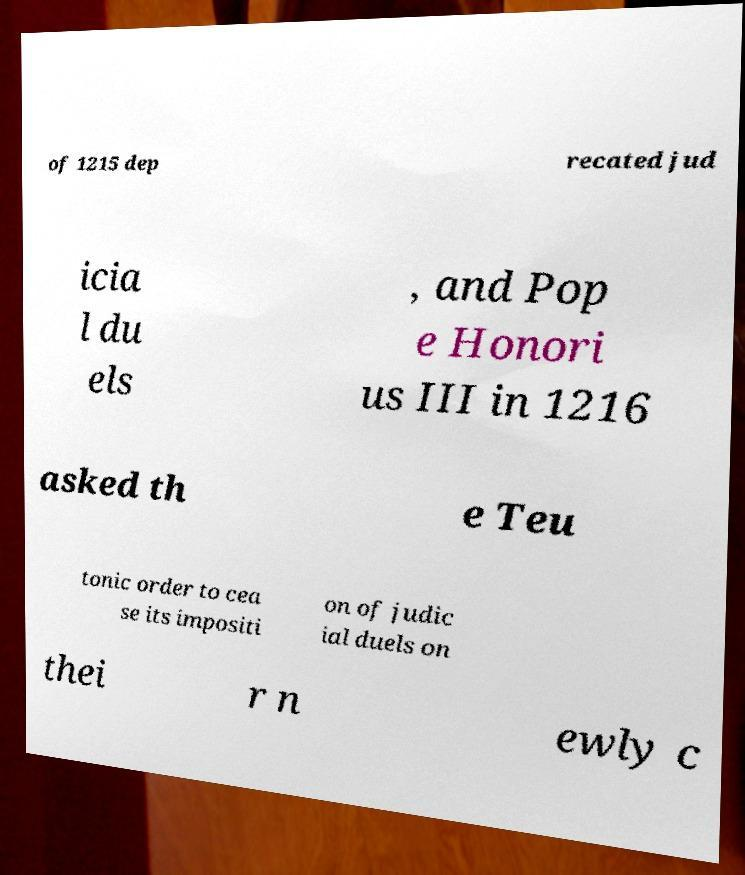Can you read and provide the text displayed in the image?This photo seems to have some interesting text. Can you extract and type it out for me? of 1215 dep recated jud icia l du els , and Pop e Honori us III in 1216 asked th e Teu tonic order to cea se its impositi on of judic ial duels on thei r n ewly c 